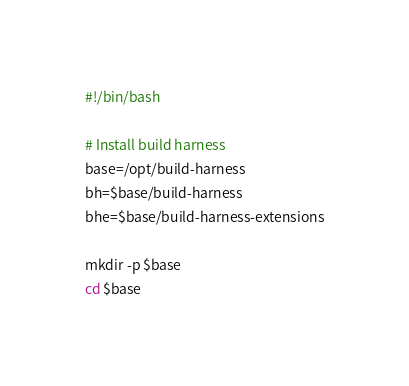Convert code to text. <code><loc_0><loc_0><loc_500><loc_500><_Bash_>#!/bin/bash

# Install build harness
base=/opt/build-harness
bh=$base/build-harness
bhe=$base/build-harness-extensions

mkdir -p $base
cd $base
</code> 